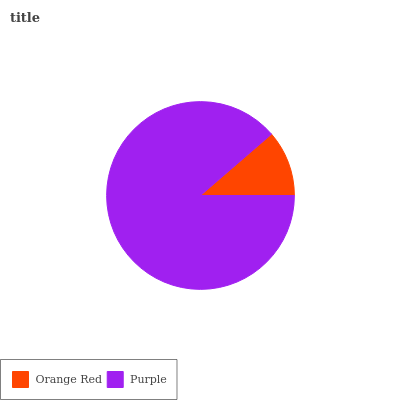Is Orange Red the minimum?
Answer yes or no. Yes. Is Purple the maximum?
Answer yes or no. Yes. Is Purple the minimum?
Answer yes or no. No. Is Purple greater than Orange Red?
Answer yes or no. Yes. Is Orange Red less than Purple?
Answer yes or no. Yes. Is Orange Red greater than Purple?
Answer yes or no. No. Is Purple less than Orange Red?
Answer yes or no. No. Is Purple the high median?
Answer yes or no. Yes. Is Orange Red the low median?
Answer yes or no. Yes. Is Orange Red the high median?
Answer yes or no. No. Is Purple the low median?
Answer yes or no. No. 